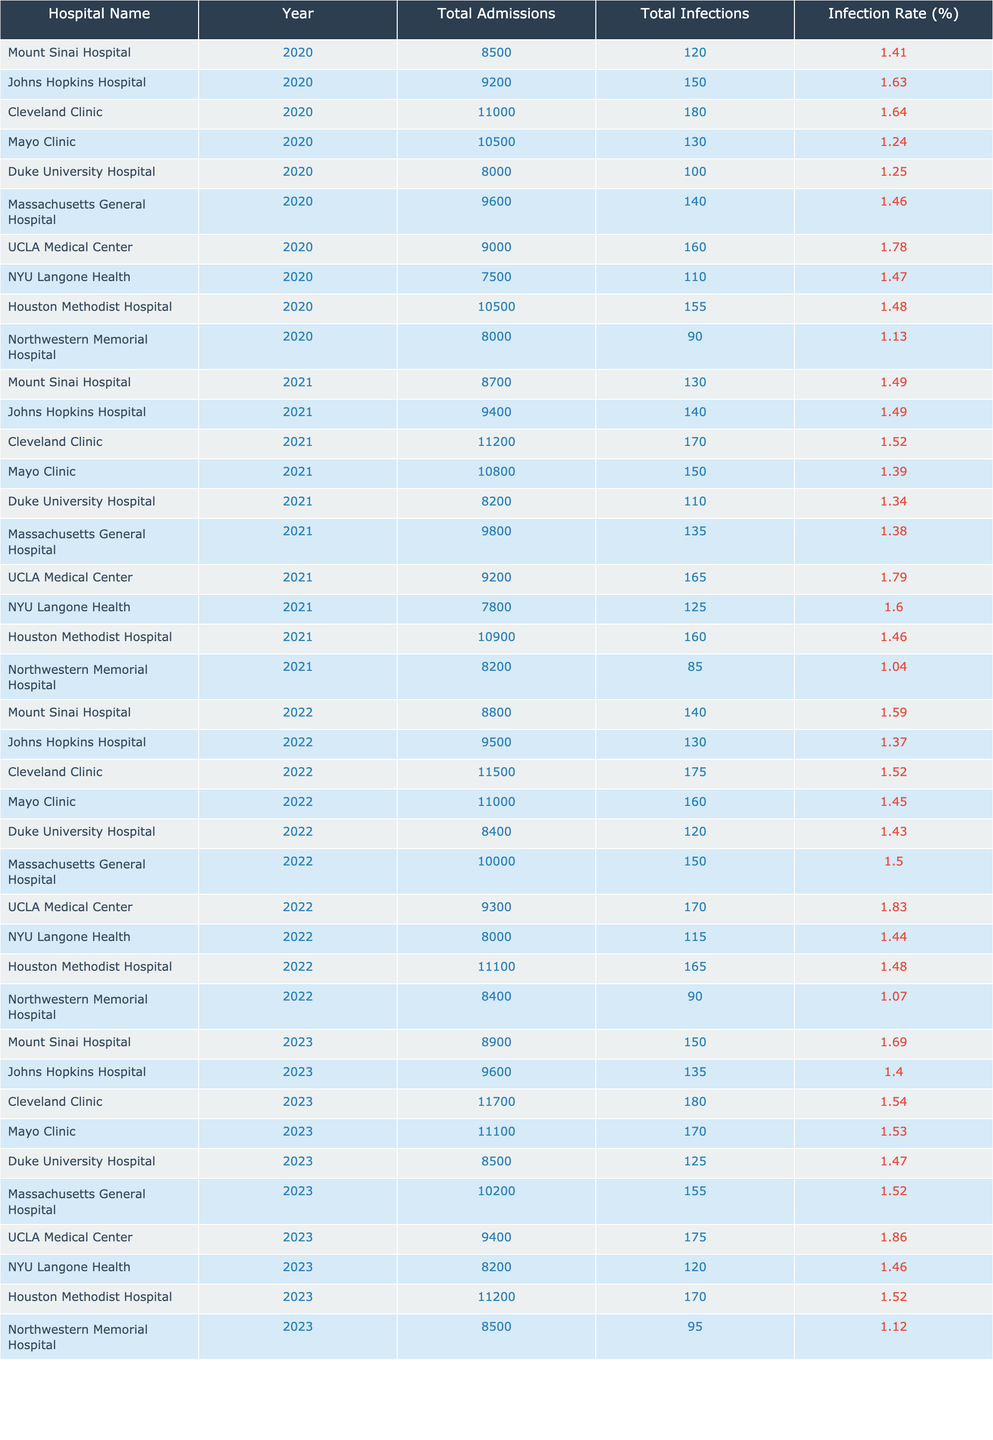What is the infection rate at Mayo Clinic in 2021? The table indicates that the total infections at Mayo Clinic in 2021 are 150 out of 10,800 total admissions. Therefore, the infection rate is provided directly as 1.39%.
Answer: 1.39% Which hospital had the highest infection rate in 2022? By examining the infection rates for all hospitals in 2022, UCLA Medical Center has the highest infection rate at 1.83%.
Answer: 1.83% What was the total number of infections across all hospitals in 2020? By summing the total infections for all hospitals in 2020, we get 120 + 150 + 180 + 130 + 100 + 140 + 160 + 110 + 155 + 90 = 1,375 infections.
Answer: 1,375 Did Northwestern Memorial Hospital's infection rate improve from 2020 to 2021? In 2020, Northwestern Memorial had an infection rate of 1.13%, which increased to 1.04% in 2021. This indicates that the infection rate did not improve.
Answer: No What is the average infection rate for John Hopkins Hospital from 2020 to 2023? The infection rates for the four years are 1.63%, 1.49%, 1.37%, and 1.40%. Summing these gives 5.89%, and dividing by 4 provides an average infection rate of 1.4725%.
Answer: 1.47% How many total infections did Cleveland Clinic have over the years 2020 to 2023? The infections in Cleveland Clinic for those years are 180 (2020), 170 (2021), 175 (2022), and 180 (2023). Summing these results (180 + 170 + 175 + 180) provides a total of 705 infections.
Answer: 705 Which hospital consistently showed an infection rate above 1.5% from 2020 to 2023? By checking each year's infection rate for each hospital, we find that UCLA Medical Center consistently had rates above 1.5% in 2020 (1.78%), 2021 (1.79%), 2022 (1.83%), and 2023 (1.86%).
Answer: UCLA Medical Center Was there a decrease in total admissions at Duke University Hospital from 2021 to 2022? In 2021, Duke University Hospital had 8,200 admissions and in 2022 it had 8,400 admissions. This shows an increase in total admissions from 2021 to 2022.
Answer: No Which hospital had the least total admissions in 2023? Reviewing the total admissions for hospitals in 2023, NYU Langone Health had the least total admissions at 8,200.
Answer: 8,200 